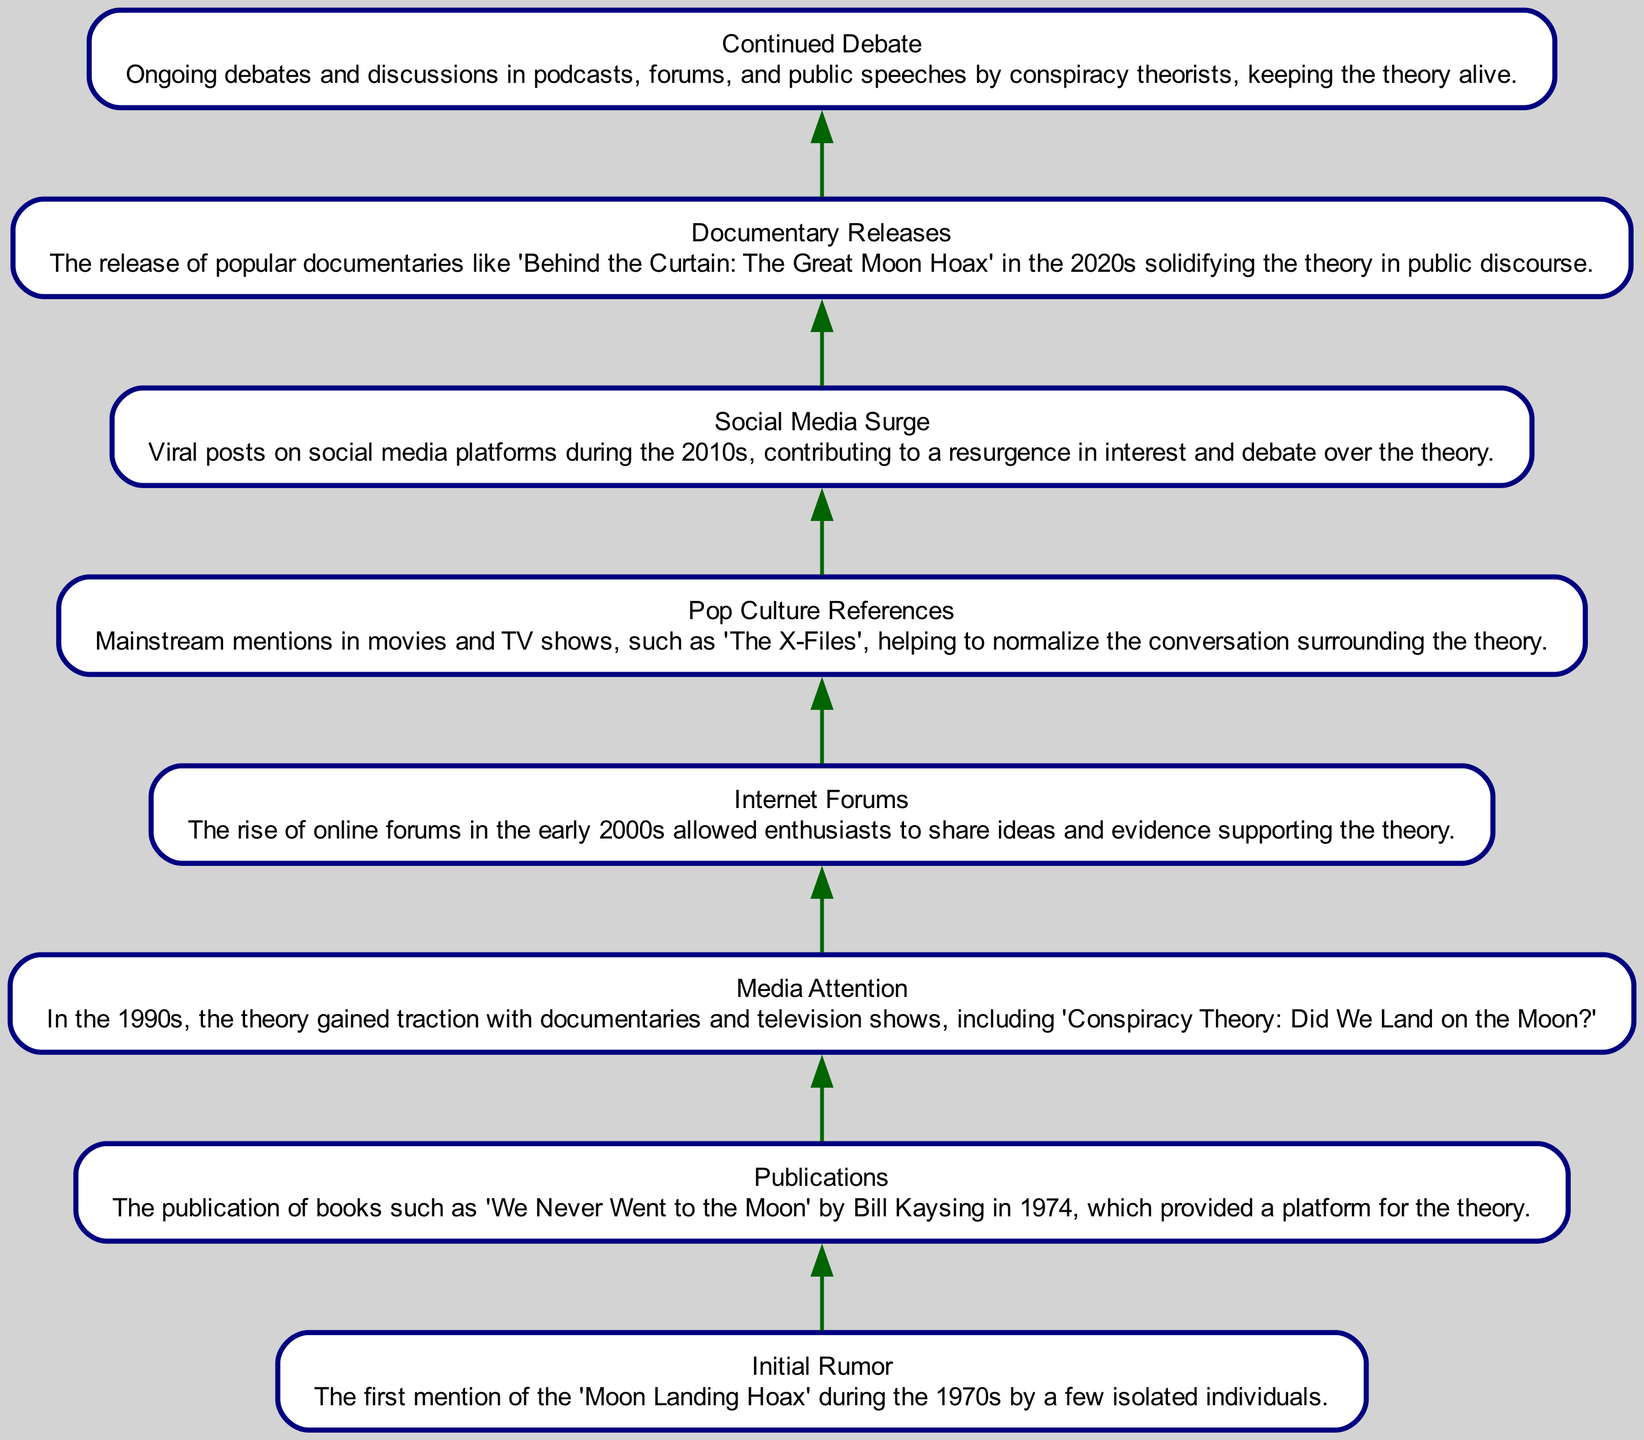What is the first element in the diagram? The first element listed in the diagram is "Initial Rumor," which is at the bottom of the flow chart marking the starting point of the theory's evolution.
Answer: Initial Rumor How many nodes are present in the diagram? By counting each of the unique elements in the flow chart, we see there are eight distinct nodes listed.
Answer: 8 What follows 'Media Attention' in the flow? The element that follows 'Media Attention' is 'Internet Forums', indicating a chronological development in the narrative of the conspiracy theory.
Answer: Internet Forums What year did 'We Never Went to the Moon' get published? The publication year of 'We Never Went to the Moon' by Bill Kaysing, which is a significant event in this conspiracy's history, is noted as 1974.
Answer: 1974 What element directly leads to 'Social Media Surge'? The direct precursor to 'Social Media Surge' is 'Pop Culture References', showing how mainstream media influence led to an increased interest in conspiracy theories.
Answer: Pop Culture References How does 'Internet Forums' contribute to the theory's evolution? 'Internet Forums' indicates a space where enthusiasts could interact, thus enhancing the spread of the conspiracy theory via shared ideas and evidence.
Answer: Encouragement of sharing ideas What decade does the 'Documentary Releases' node fall into? The node 'Documentary Releases' is placed in the 2020s, signifying its recent impact on popular culture regarding the conspiracy theory.
Answer: 2020s How are ongoing debates maintained according to the diagram? The diagram states ongoing debates are sustained through 'Continued Debate,' highlighted by discussions in multiple platforms and formats including podcasts and forums.
Answer: Continued Debate Which node indicates a surge of interest in the 2010s? The node that signifies a surge of interest during the 2010s is 'Social Media Surge', indicating a revitalization of public discourse on the topic.
Answer: Social Media Surge 